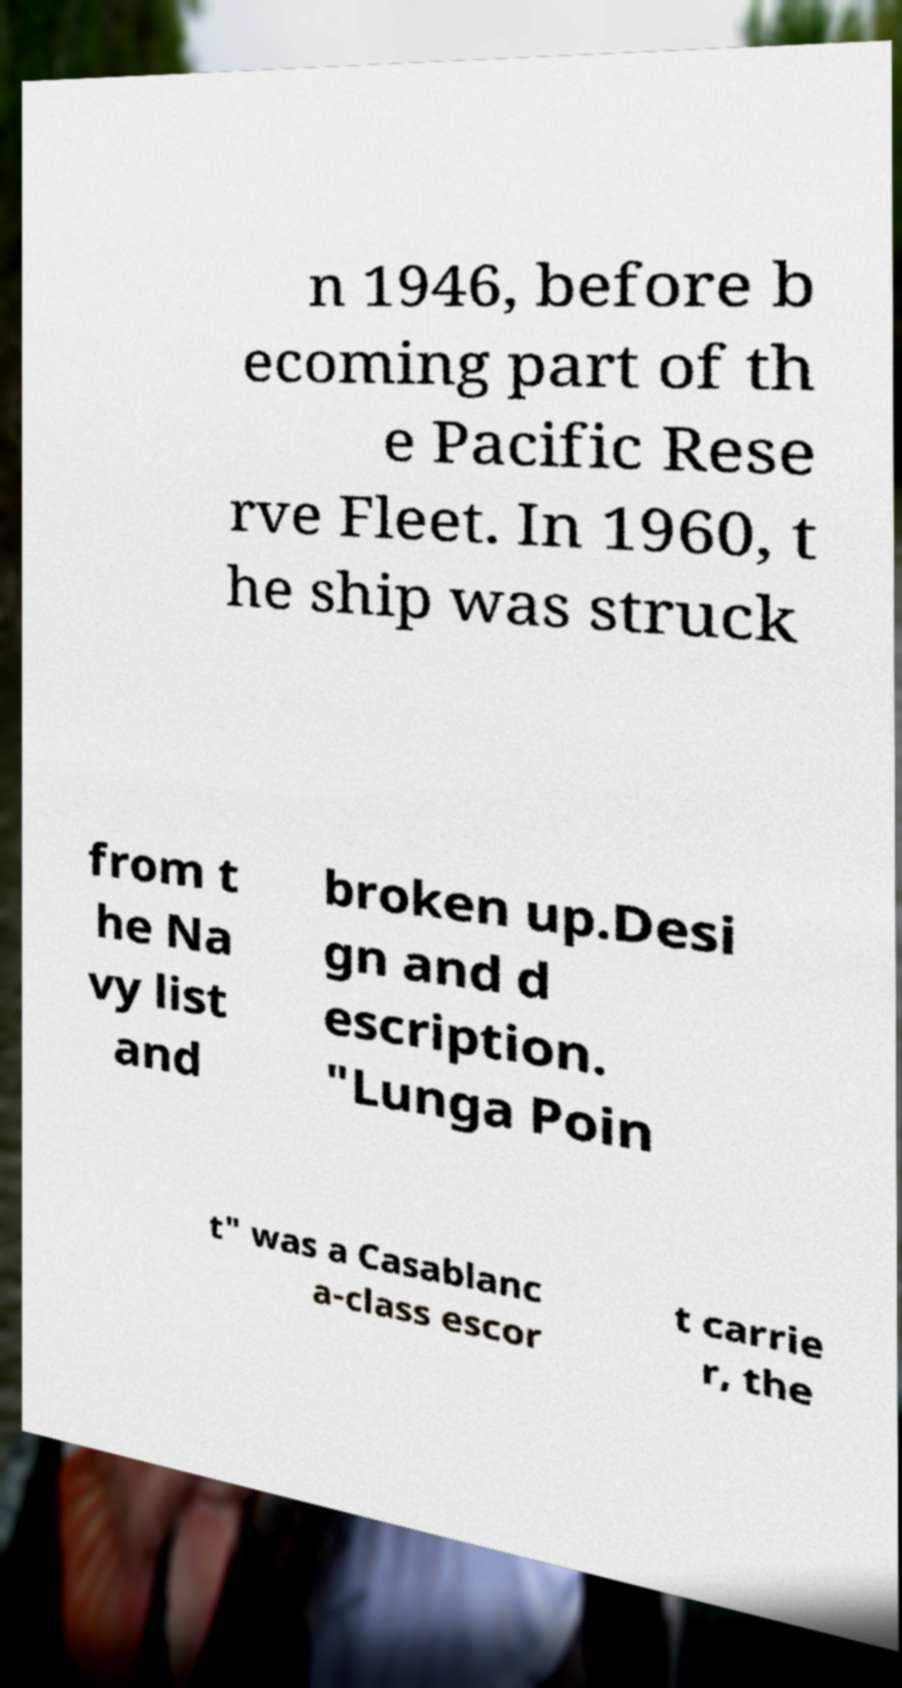Could you assist in decoding the text presented in this image and type it out clearly? n 1946, before b ecoming part of th e Pacific Rese rve Fleet. In 1960, t he ship was struck from t he Na vy list and broken up.Desi gn and d escription. "Lunga Poin t" was a Casablanc a-class escor t carrie r, the 